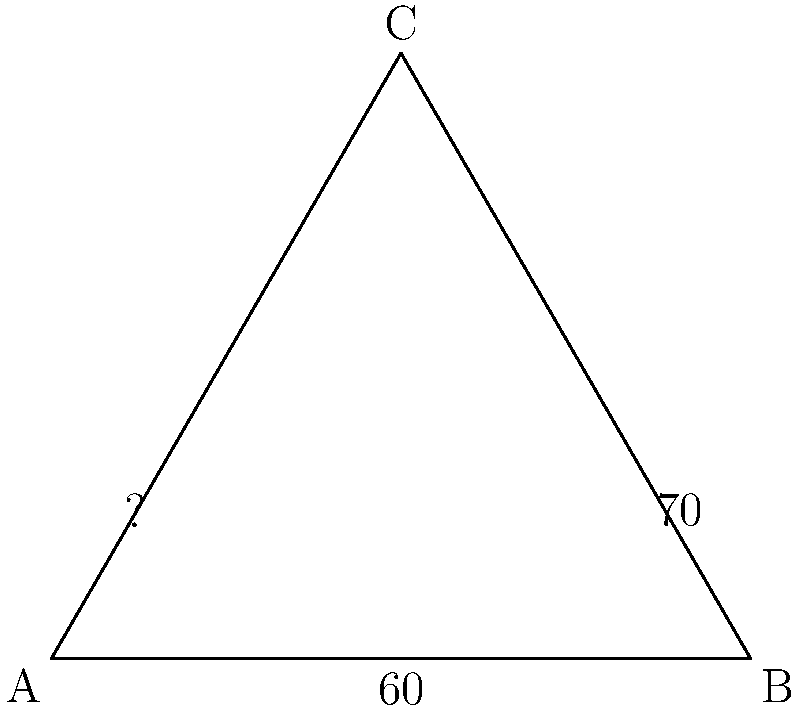A conservation biologist is tracking the flight paths of an elusive bird species between three nesting sites (A, B, and C) forming a triangle. The angle at site B is $60°$, and the angle between the flight paths BC and AC is $70°$. What is the measure of the angle at site A? Let's solve this step-by-step:

1) In any triangle, the sum of all interior angles is always $180°$.

2) Let's denote the angle at site A as $x°$.

3) We know that:
   - The angle at B is $60°$
   - The angle between BC and AC is $70°$

4) The angle at C can be calculated as:
   $180° - 70° = 110°$

5) Now we can set up an equation based on the fact that the sum of all angles in a triangle is $180°$:

   $x° + 60° + 110° = 180°$

6) Simplify:
   $x° + 170° = 180°$

7) Subtract 170° from both sides:
   $x° = 180° - 170° = 10°$

Therefore, the measure of the angle at site A is $10°$.
Answer: $10°$ 